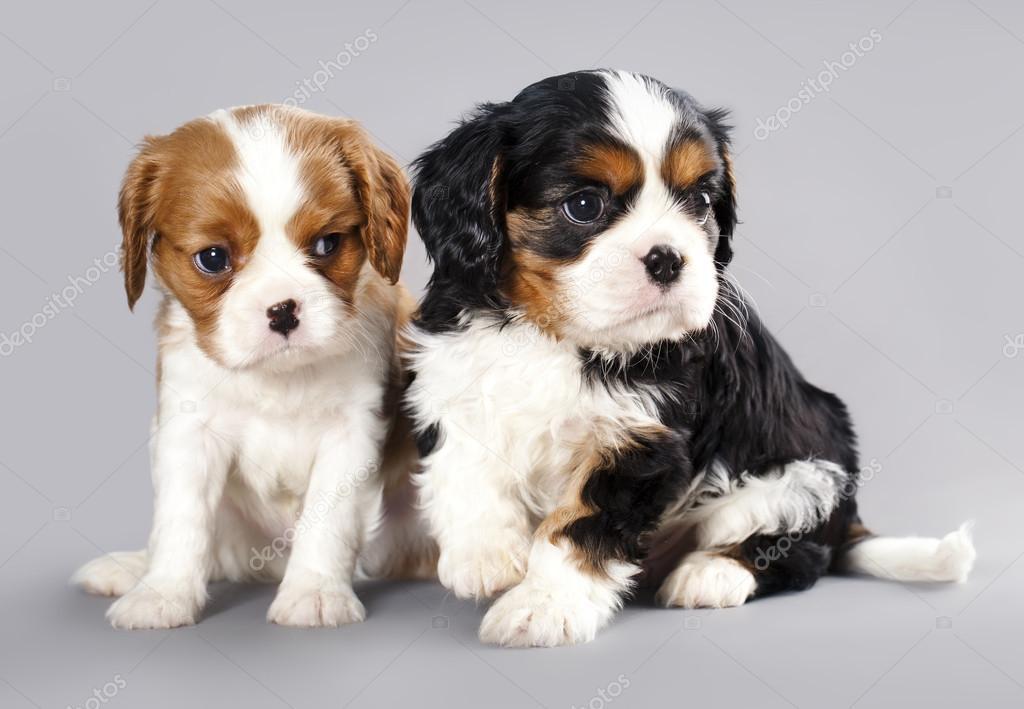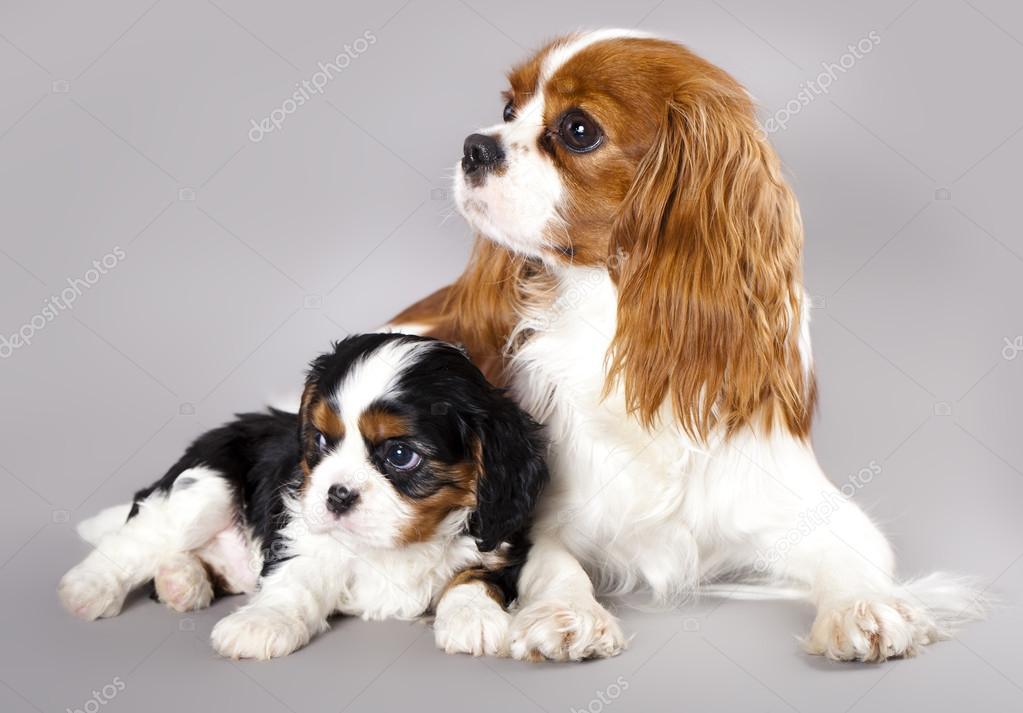The first image is the image on the left, the second image is the image on the right. Analyze the images presented: Is the assertion "The right and left images contain the same number of puppies." valid? Answer yes or no. Yes. 